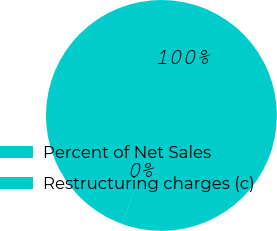Convert chart to OTSL. <chart><loc_0><loc_0><loc_500><loc_500><pie_chart><fcel>Percent of Net Sales<fcel>Restructuring charges (c)<nl><fcel>99.98%<fcel>0.02%<nl></chart> 